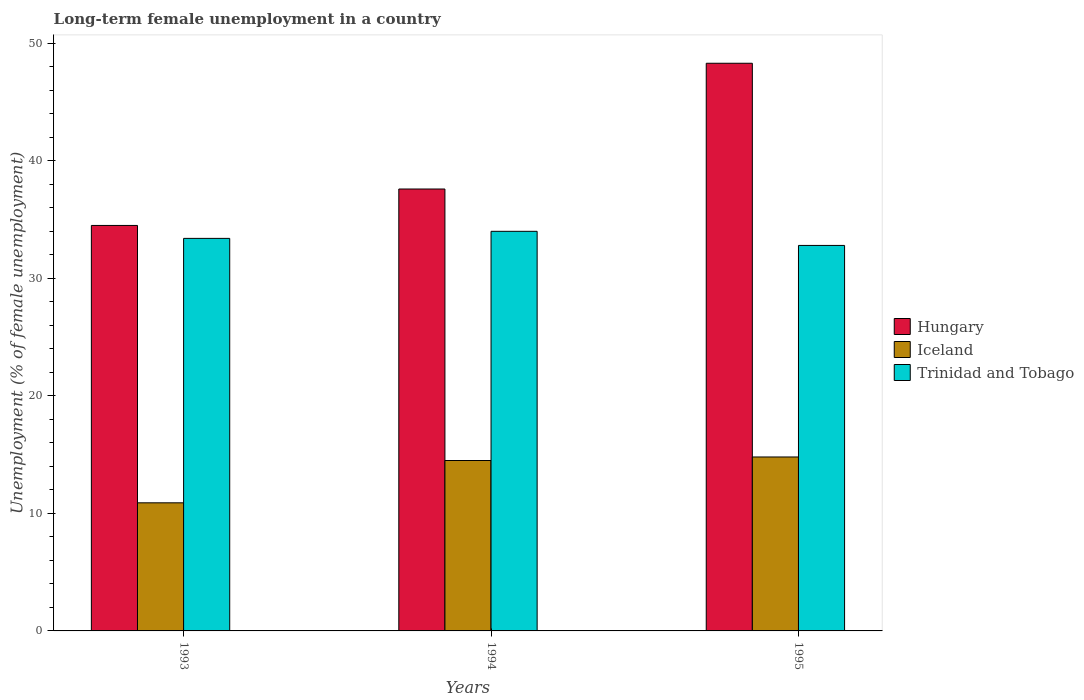Are the number of bars on each tick of the X-axis equal?
Offer a very short reply. Yes. How many bars are there on the 2nd tick from the left?
Offer a very short reply. 3. How many bars are there on the 3rd tick from the right?
Offer a terse response. 3. What is the label of the 3rd group of bars from the left?
Offer a terse response. 1995. What is the percentage of long-term unemployed female population in Hungary in 1993?
Make the answer very short. 34.5. Across all years, what is the minimum percentage of long-term unemployed female population in Iceland?
Ensure brevity in your answer.  10.9. In which year was the percentage of long-term unemployed female population in Hungary minimum?
Offer a terse response. 1993. What is the total percentage of long-term unemployed female population in Iceland in the graph?
Your answer should be compact. 40.2. What is the difference between the percentage of long-term unemployed female population in Hungary in 1993 and that in 1995?
Ensure brevity in your answer.  -13.8. What is the difference between the percentage of long-term unemployed female population in Trinidad and Tobago in 1993 and the percentage of long-term unemployed female population in Iceland in 1995?
Your response must be concise. 18.6. What is the average percentage of long-term unemployed female population in Trinidad and Tobago per year?
Offer a very short reply. 33.4. In the year 1993, what is the difference between the percentage of long-term unemployed female population in Trinidad and Tobago and percentage of long-term unemployed female population in Hungary?
Keep it short and to the point. -1.1. In how many years, is the percentage of long-term unemployed female population in Hungary greater than 28 %?
Your answer should be very brief. 3. What is the ratio of the percentage of long-term unemployed female population in Trinidad and Tobago in 1993 to that in 1995?
Provide a short and direct response. 1.02. Is the percentage of long-term unemployed female population in Hungary in 1993 less than that in 1994?
Keep it short and to the point. Yes. What is the difference between the highest and the second highest percentage of long-term unemployed female population in Iceland?
Your response must be concise. 0.3. What is the difference between the highest and the lowest percentage of long-term unemployed female population in Iceland?
Give a very brief answer. 3.9. What does the 2nd bar from the left in 1993 represents?
Your answer should be very brief. Iceland. How many bars are there?
Ensure brevity in your answer.  9. How many years are there in the graph?
Your response must be concise. 3. What is the difference between two consecutive major ticks on the Y-axis?
Offer a very short reply. 10. Does the graph contain any zero values?
Provide a succinct answer. No. Where does the legend appear in the graph?
Your answer should be compact. Center right. How are the legend labels stacked?
Keep it short and to the point. Vertical. What is the title of the graph?
Your answer should be very brief. Long-term female unemployment in a country. What is the label or title of the Y-axis?
Offer a terse response. Unemployment (% of female unemployment). What is the Unemployment (% of female unemployment) in Hungary in 1993?
Offer a very short reply. 34.5. What is the Unemployment (% of female unemployment) in Iceland in 1993?
Provide a short and direct response. 10.9. What is the Unemployment (% of female unemployment) in Trinidad and Tobago in 1993?
Make the answer very short. 33.4. What is the Unemployment (% of female unemployment) of Hungary in 1994?
Provide a succinct answer. 37.6. What is the Unemployment (% of female unemployment) in Trinidad and Tobago in 1994?
Provide a short and direct response. 34. What is the Unemployment (% of female unemployment) of Hungary in 1995?
Your answer should be compact. 48.3. What is the Unemployment (% of female unemployment) of Iceland in 1995?
Offer a terse response. 14.8. What is the Unemployment (% of female unemployment) in Trinidad and Tobago in 1995?
Keep it short and to the point. 32.8. Across all years, what is the maximum Unemployment (% of female unemployment) in Hungary?
Keep it short and to the point. 48.3. Across all years, what is the maximum Unemployment (% of female unemployment) in Iceland?
Your answer should be compact. 14.8. Across all years, what is the minimum Unemployment (% of female unemployment) in Hungary?
Your answer should be very brief. 34.5. Across all years, what is the minimum Unemployment (% of female unemployment) of Iceland?
Provide a succinct answer. 10.9. Across all years, what is the minimum Unemployment (% of female unemployment) in Trinidad and Tobago?
Offer a very short reply. 32.8. What is the total Unemployment (% of female unemployment) of Hungary in the graph?
Give a very brief answer. 120.4. What is the total Unemployment (% of female unemployment) in Iceland in the graph?
Keep it short and to the point. 40.2. What is the total Unemployment (% of female unemployment) of Trinidad and Tobago in the graph?
Keep it short and to the point. 100.2. What is the difference between the Unemployment (% of female unemployment) of Hungary in 1993 and that in 1994?
Provide a short and direct response. -3.1. What is the difference between the Unemployment (% of female unemployment) in Trinidad and Tobago in 1993 and that in 1994?
Give a very brief answer. -0.6. What is the difference between the Unemployment (% of female unemployment) in Trinidad and Tobago in 1993 and that in 1995?
Offer a very short reply. 0.6. What is the difference between the Unemployment (% of female unemployment) in Hungary in 1994 and that in 1995?
Offer a very short reply. -10.7. What is the difference between the Unemployment (% of female unemployment) in Hungary in 1993 and the Unemployment (% of female unemployment) in Trinidad and Tobago in 1994?
Offer a very short reply. 0.5. What is the difference between the Unemployment (% of female unemployment) of Iceland in 1993 and the Unemployment (% of female unemployment) of Trinidad and Tobago in 1994?
Your answer should be very brief. -23.1. What is the difference between the Unemployment (% of female unemployment) in Hungary in 1993 and the Unemployment (% of female unemployment) in Trinidad and Tobago in 1995?
Ensure brevity in your answer.  1.7. What is the difference between the Unemployment (% of female unemployment) in Iceland in 1993 and the Unemployment (% of female unemployment) in Trinidad and Tobago in 1995?
Ensure brevity in your answer.  -21.9. What is the difference between the Unemployment (% of female unemployment) in Hungary in 1994 and the Unemployment (% of female unemployment) in Iceland in 1995?
Give a very brief answer. 22.8. What is the difference between the Unemployment (% of female unemployment) in Iceland in 1994 and the Unemployment (% of female unemployment) in Trinidad and Tobago in 1995?
Your answer should be very brief. -18.3. What is the average Unemployment (% of female unemployment) of Hungary per year?
Provide a short and direct response. 40.13. What is the average Unemployment (% of female unemployment) in Trinidad and Tobago per year?
Offer a very short reply. 33.4. In the year 1993, what is the difference between the Unemployment (% of female unemployment) in Hungary and Unemployment (% of female unemployment) in Iceland?
Keep it short and to the point. 23.6. In the year 1993, what is the difference between the Unemployment (% of female unemployment) of Hungary and Unemployment (% of female unemployment) of Trinidad and Tobago?
Provide a succinct answer. 1.1. In the year 1993, what is the difference between the Unemployment (% of female unemployment) in Iceland and Unemployment (% of female unemployment) in Trinidad and Tobago?
Give a very brief answer. -22.5. In the year 1994, what is the difference between the Unemployment (% of female unemployment) in Hungary and Unemployment (% of female unemployment) in Iceland?
Offer a very short reply. 23.1. In the year 1994, what is the difference between the Unemployment (% of female unemployment) in Iceland and Unemployment (% of female unemployment) in Trinidad and Tobago?
Give a very brief answer. -19.5. In the year 1995, what is the difference between the Unemployment (% of female unemployment) of Hungary and Unemployment (% of female unemployment) of Iceland?
Your response must be concise. 33.5. In the year 1995, what is the difference between the Unemployment (% of female unemployment) in Iceland and Unemployment (% of female unemployment) in Trinidad and Tobago?
Provide a short and direct response. -18. What is the ratio of the Unemployment (% of female unemployment) in Hungary in 1993 to that in 1994?
Your response must be concise. 0.92. What is the ratio of the Unemployment (% of female unemployment) in Iceland in 1993 to that in 1994?
Provide a succinct answer. 0.75. What is the ratio of the Unemployment (% of female unemployment) of Trinidad and Tobago in 1993 to that in 1994?
Make the answer very short. 0.98. What is the ratio of the Unemployment (% of female unemployment) in Hungary in 1993 to that in 1995?
Your response must be concise. 0.71. What is the ratio of the Unemployment (% of female unemployment) in Iceland in 1993 to that in 1995?
Ensure brevity in your answer.  0.74. What is the ratio of the Unemployment (% of female unemployment) in Trinidad and Tobago in 1993 to that in 1995?
Your answer should be very brief. 1.02. What is the ratio of the Unemployment (% of female unemployment) in Hungary in 1994 to that in 1995?
Keep it short and to the point. 0.78. What is the ratio of the Unemployment (% of female unemployment) of Iceland in 1994 to that in 1995?
Make the answer very short. 0.98. What is the ratio of the Unemployment (% of female unemployment) in Trinidad and Tobago in 1994 to that in 1995?
Provide a short and direct response. 1.04. What is the difference between the highest and the second highest Unemployment (% of female unemployment) of Iceland?
Offer a very short reply. 0.3. What is the difference between the highest and the lowest Unemployment (% of female unemployment) of Hungary?
Keep it short and to the point. 13.8. What is the difference between the highest and the lowest Unemployment (% of female unemployment) in Iceland?
Your answer should be compact. 3.9. What is the difference between the highest and the lowest Unemployment (% of female unemployment) of Trinidad and Tobago?
Offer a terse response. 1.2. 